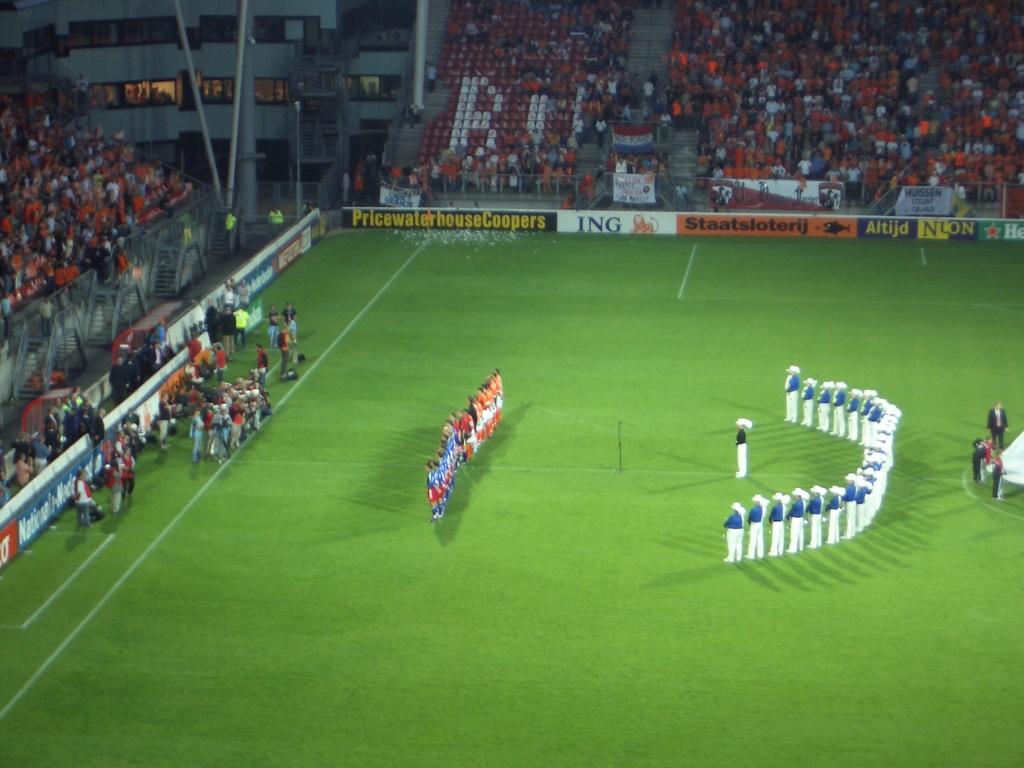Which bank is advertised on the white banner?
Offer a very short reply. Ing. What is advertised in the blue and yellow banner?
Provide a short and direct response. Pricewaterhousecoopers. 